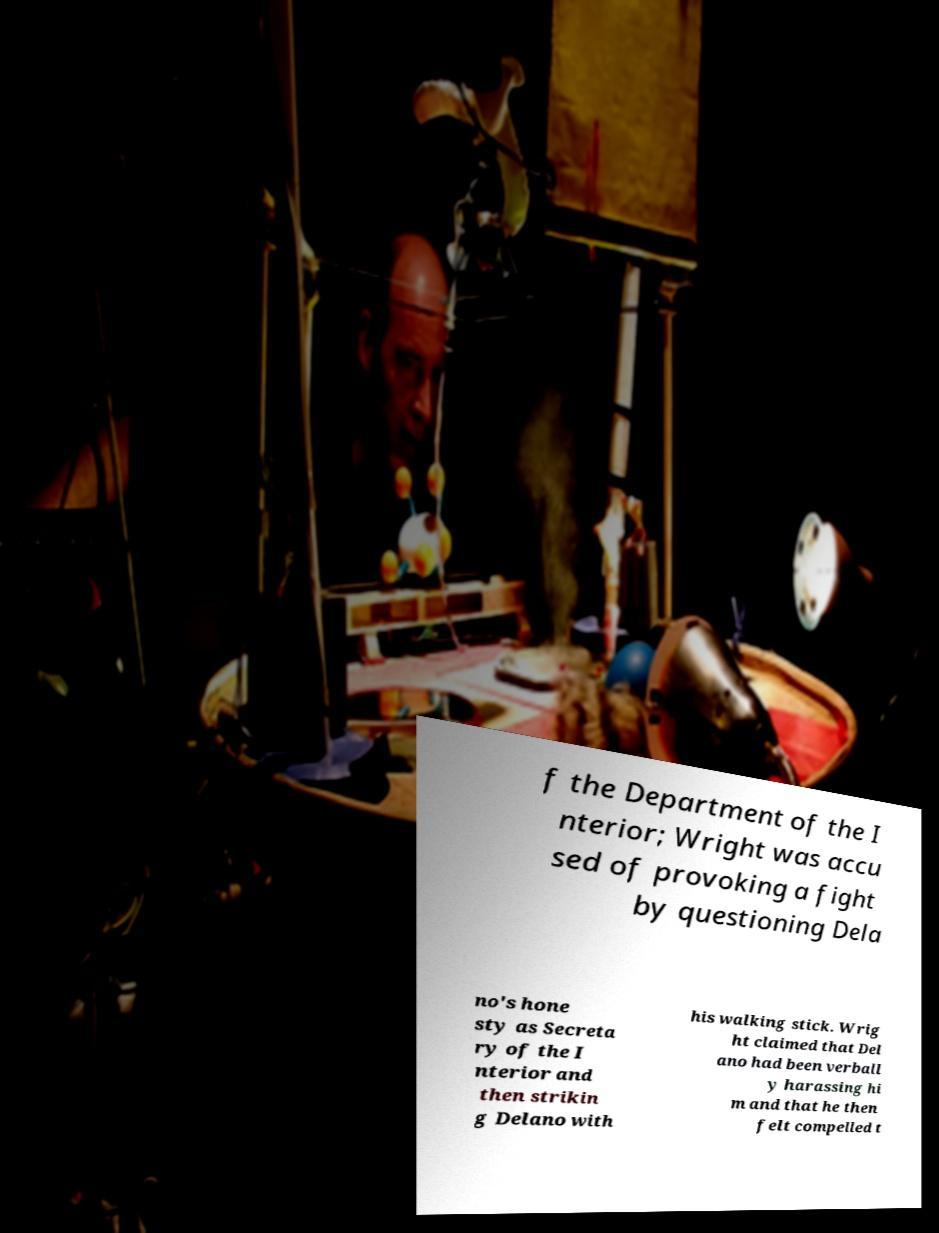I need the written content from this picture converted into text. Can you do that? f the Department of the I nterior; Wright was accu sed of provoking a fight by questioning Dela no's hone sty as Secreta ry of the I nterior and then strikin g Delano with his walking stick. Wrig ht claimed that Del ano had been verball y harassing hi m and that he then felt compelled t 